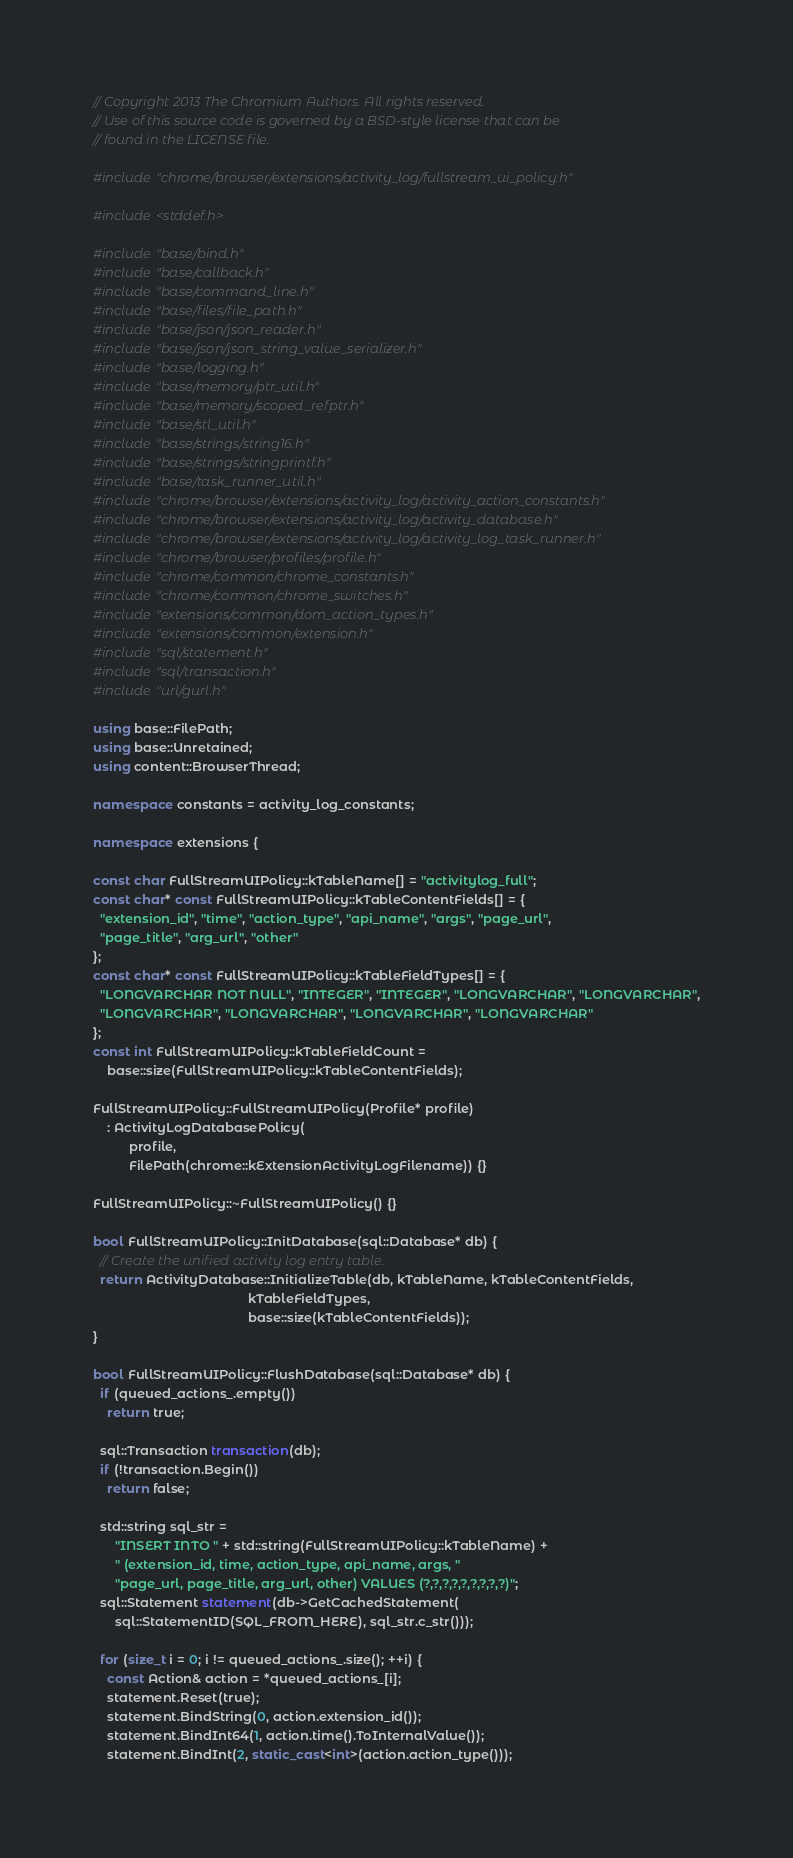Convert code to text. <code><loc_0><loc_0><loc_500><loc_500><_C++_>// Copyright 2013 The Chromium Authors. All rights reserved.
// Use of this source code is governed by a BSD-style license that can be
// found in the LICENSE file.

#include "chrome/browser/extensions/activity_log/fullstream_ui_policy.h"

#include <stddef.h>

#include "base/bind.h"
#include "base/callback.h"
#include "base/command_line.h"
#include "base/files/file_path.h"
#include "base/json/json_reader.h"
#include "base/json/json_string_value_serializer.h"
#include "base/logging.h"
#include "base/memory/ptr_util.h"
#include "base/memory/scoped_refptr.h"
#include "base/stl_util.h"
#include "base/strings/string16.h"
#include "base/strings/stringprintf.h"
#include "base/task_runner_util.h"
#include "chrome/browser/extensions/activity_log/activity_action_constants.h"
#include "chrome/browser/extensions/activity_log/activity_database.h"
#include "chrome/browser/extensions/activity_log/activity_log_task_runner.h"
#include "chrome/browser/profiles/profile.h"
#include "chrome/common/chrome_constants.h"
#include "chrome/common/chrome_switches.h"
#include "extensions/common/dom_action_types.h"
#include "extensions/common/extension.h"
#include "sql/statement.h"
#include "sql/transaction.h"
#include "url/gurl.h"

using base::FilePath;
using base::Unretained;
using content::BrowserThread;

namespace constants = activity_log_constants;

namespace extensions {

const char FullStreamUIPolicy::kTableName[] = "activitylog_full";
const char* const FullStreamUIPolicy::kTableContentFields[] = {
  "extension_id", "time", "action_type", "api_name", "args", "page_url",
  "page_title", "arg_url", "other"
};
const char* const FullStreamUIPolicy::kTableFieldTypes[] = {
  "LONGVARCHAR NOT NULL", "INTEGER", "INTEGER", "LONGVARCHAR", "LONGVARCHAR",
  "LONGVARCHAR", "LONGVARCHAR", "LONGVARCHAR", "LONGVARCHAR"
};
const int FullStreamUIPolicy::kTableFieldCount =
    base::size(FullStreamUIPolicy::kTableContentFields);

FullStreamUIPolicy::FullStreamUIPolicy(Profile* profile)
    : ActivityLogDatabasePolicy(
          profile,
          FilePath(chrome::kExtensionActivityLogFilename)) {}

FullStreamUIPolicy::~FullStreamUIPolicy() {}

bool FullStreamUIPolicy::InitDatabase(sql::Database* db) {
  // Create the unified activity log entry table.
  return ActivityDatabase::InitializeTable(db, kTableName, kTableContentFields,
                                           kTableFieldTypes,
                                           base::size(kTableContentFields));
}

bool FullStreamUIPolicy::FlushDatabase(sql::Database* db) {
  if (queued_actions_.empty())
    return true;

  sql::Transaction transaction(db);
  if (!transaction.Begin())
    return false;

  std::string sql_str =
      "INSERT INTO " + std::string(FullStreamUIPolicy::kTableName) +
      " (extension_id, time, action_type, api_name, args, "
      "page_url, page_title, arg_url, other) VALUES (?,?,?,?,?,?,?,?,?)";
  sql::Statement statement(db->GetCachedStatement(
      sql::StatementID(SQL_FROM_HERE), sql_str.c_str()));

  for (size_t i = 0; i != queued_actions_.size(); ++i) {
    const Action& action = *queued_actions_[i];
    statement.Reset(true);
    statement.BindString(0, action.extension_id());
    statement.BindInt64(1, action.time().ToInternalValue());
    statement.BindInt(2, static_cast<int>(action.action_type()));</code> 